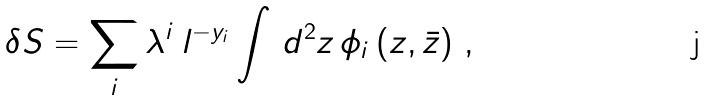Convert formula to latex. <formula><loc_0><loc_0><loc_500><loc_500>\delta S = \sum _ { i } \lambda ^ { i } \, l ^ { - y _ { i } } \int \, d ^ { 2 } z \, \phi _ { i } \, ( z , \bar { z } ) \ ,</formula> 